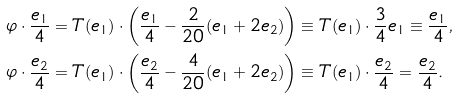<formula> <loc_0><loc_0><loc_500><loc_500>\varphi \cdot \frac { e _ { 1 } } { 4 } & = T ( e _ { 1 } ) \cdot \left ( \frac { e _ { 1 } } { 4 } - \frac { 2 } { 2 0 } ( e _ { 1 } + 2 e _ { 2 } ) \right ) \equiv T ( e _ { 1 } ) \cdot \frac { 3 } { 4 } e _ { 1 } \equiv \frac { e _ { 1 } } { 4 } , \\ \varphi \cdot \frac { e _ { 2 } } { 4 } & = T ( e _ { 1 } ) \cdot \left ( \frac { e _ { 2 } } { 4 } - \frac { 4 } { 2 0 } ( e _ { 1 } + 2 e _ { 2 } ) \right ) \equiv T ( e _ { 1 } ) \cdot \frac { e _ { 2 } } { 4 } = \frac { e _ { 2 } } { 4 } .</formula> 